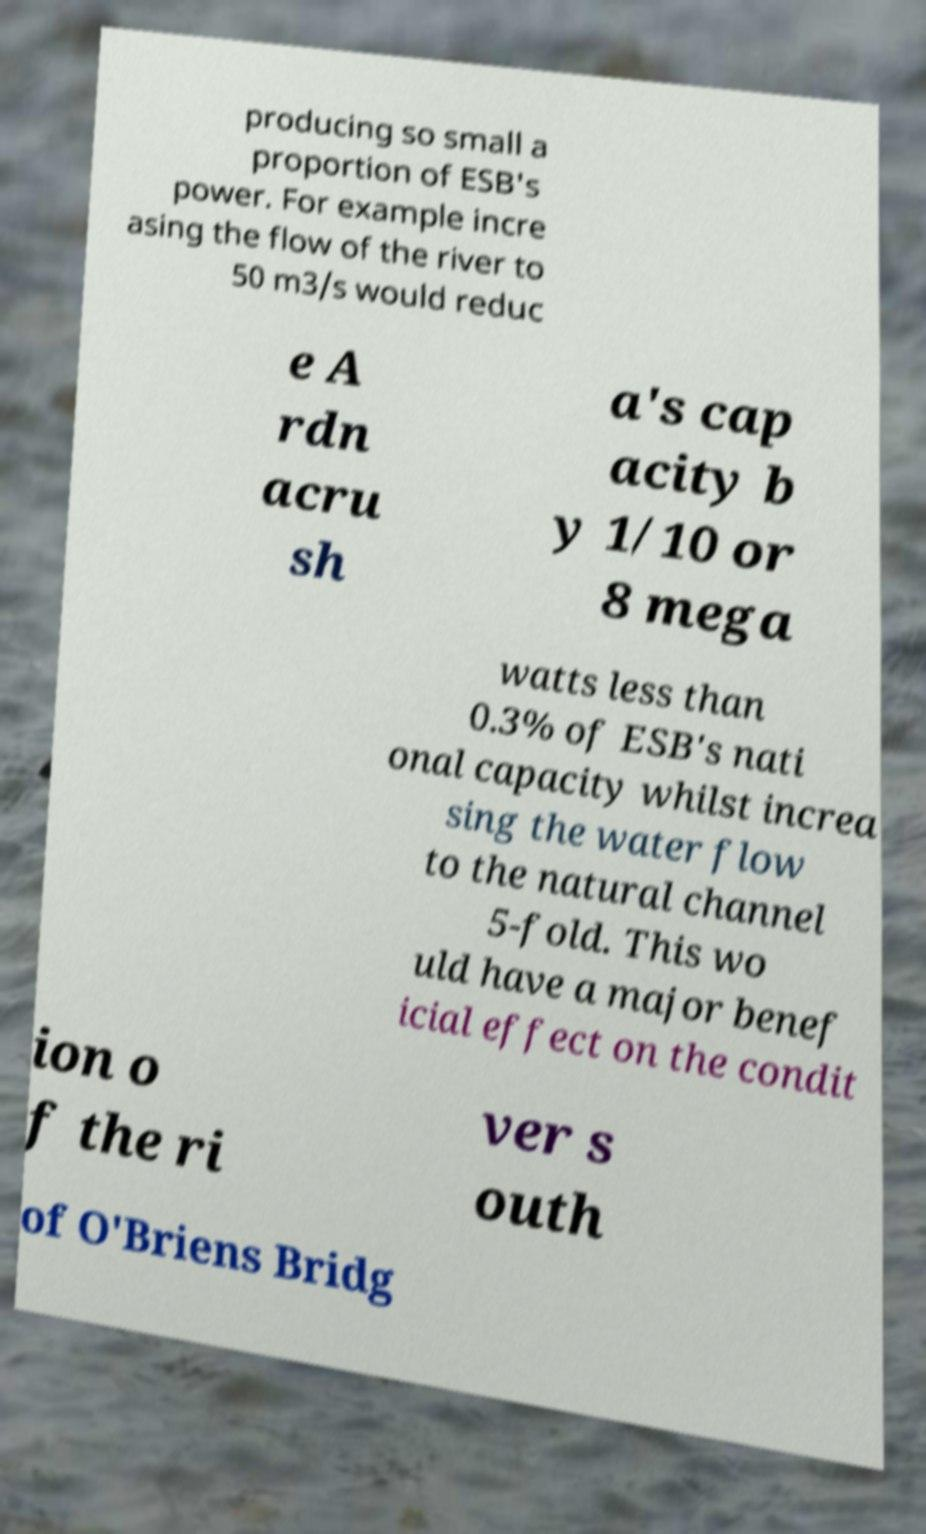There's text embedded in this image that I need extracted. Can you transcribe it verbatim? producing so small a proportion of ESB's power. For example incre asing the flow of the river to 50 m3/s would reduc e A rdn acru sh a's cap acity b y 1/10 or 8 mega watts less than 0.3% of ESB's nati onal capacity whilst increa sing the water flow to the natural channel 5-fold. This wo uld have a major benef icial effect on the condit ion o f the ri ver s outh of O'Briens Bridg 